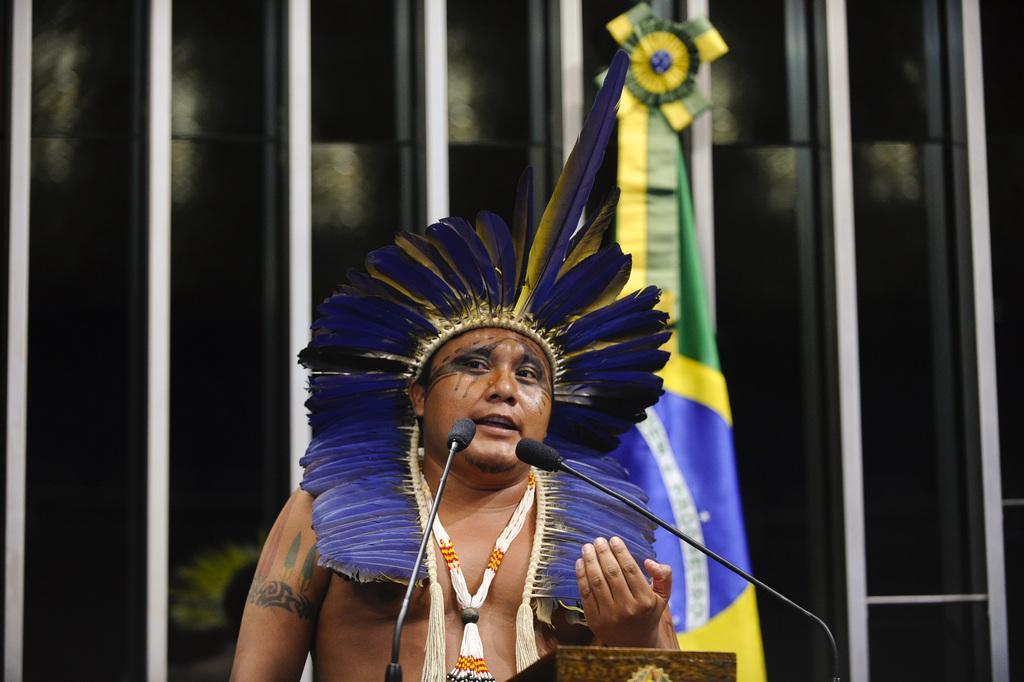Could you give a brief overview of what you see in this image? In this image there is a tribe who is standing in front of two mikes. There is a flag behind the man. 